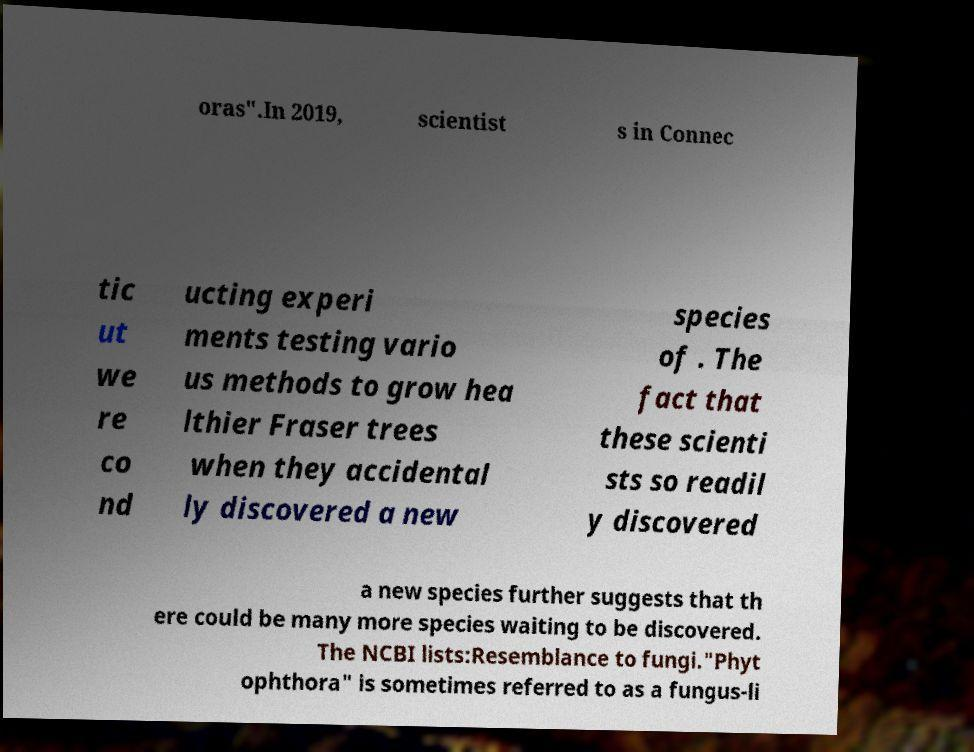There's text embedded in this image that I need extracted. Can you transcribe it verbatim? oras".In 2019, scientist s in Connec tic ut we re co nd ucting experi ments testing vario us methods to grow hea lthier Fraser trees when they accidental ly discovered a new species of . The fact that these scienti sts so readil y discovered a new species further suggests that th ere could be many more species waiting to be discovered. The NCBI lists:Resemblance to fungi."Phyt ophthora" is sometimes referred to as a fungus-li 